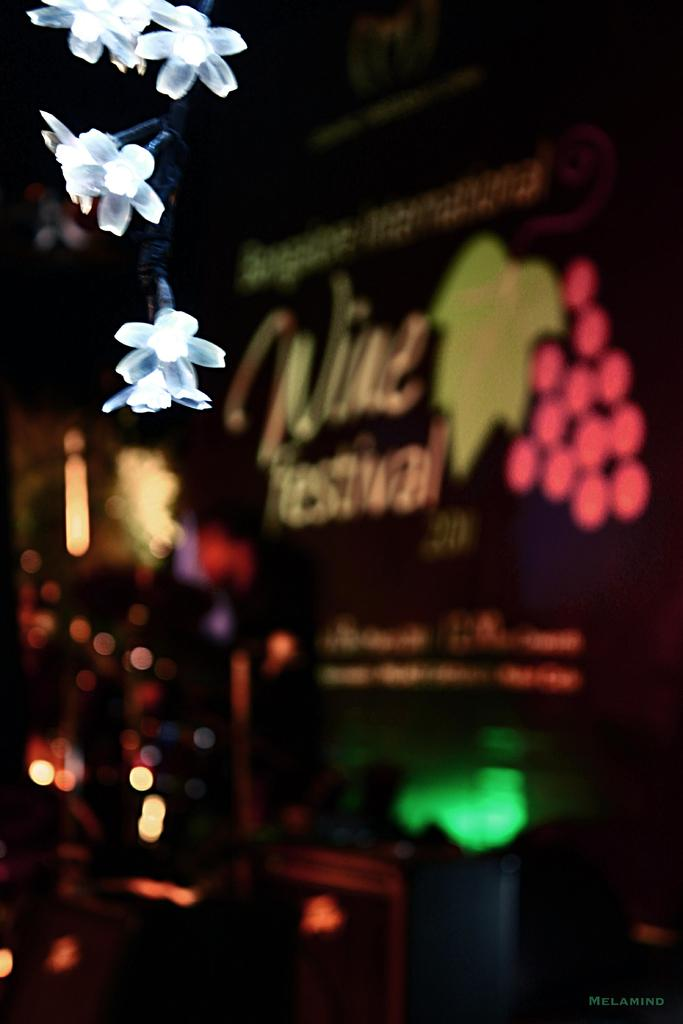What type of lights are present in the front of the image? There are flower lights in the front of the image. What else can be seen in the image besides the flower lights? There is some text visible in the background of the image. How would you describe the appearance of the background? The background appears blurry. Can you see a giraffe smiling in the image? There is no giraffe or smile present in the image. 